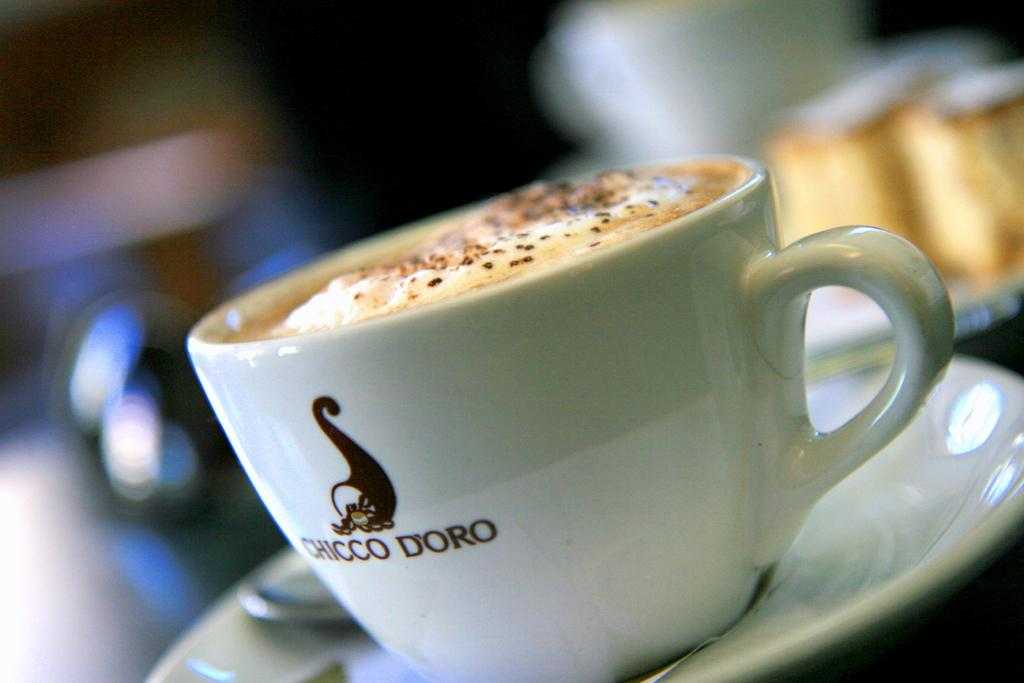What type of dishware is present in the image? There is a tea cup and a saucer in the image. What utensil is visible in the image? There is a spoon in the image. Can you describe the background of the image? The background of the image is blurred. What type of activity is taking place in the ocean in the image? There is no ocean present in the image, and therefore no activity can be observed. Can you hear the people laughing in the image? There are no people or sounds of laughter present in the image. 